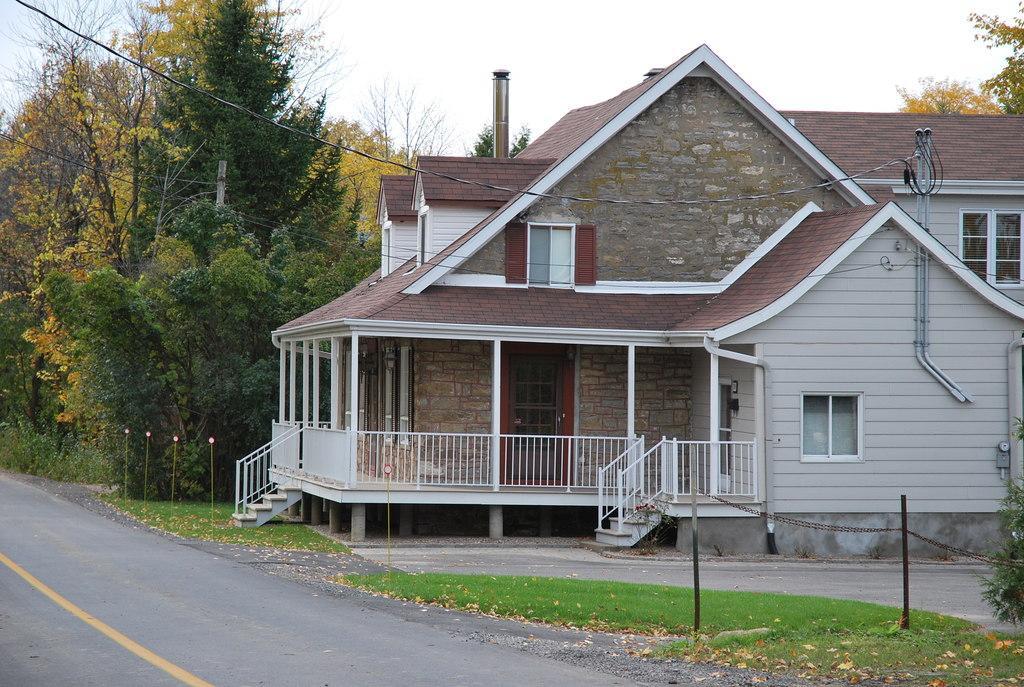Could you give a brief overview of what you see in this image? In this image I can see road. To the side few the road there is a house which is in white and brown color. I can see the railing and windows to the house. To the side there are many trees and also poles. In the background I can see the white sky. 